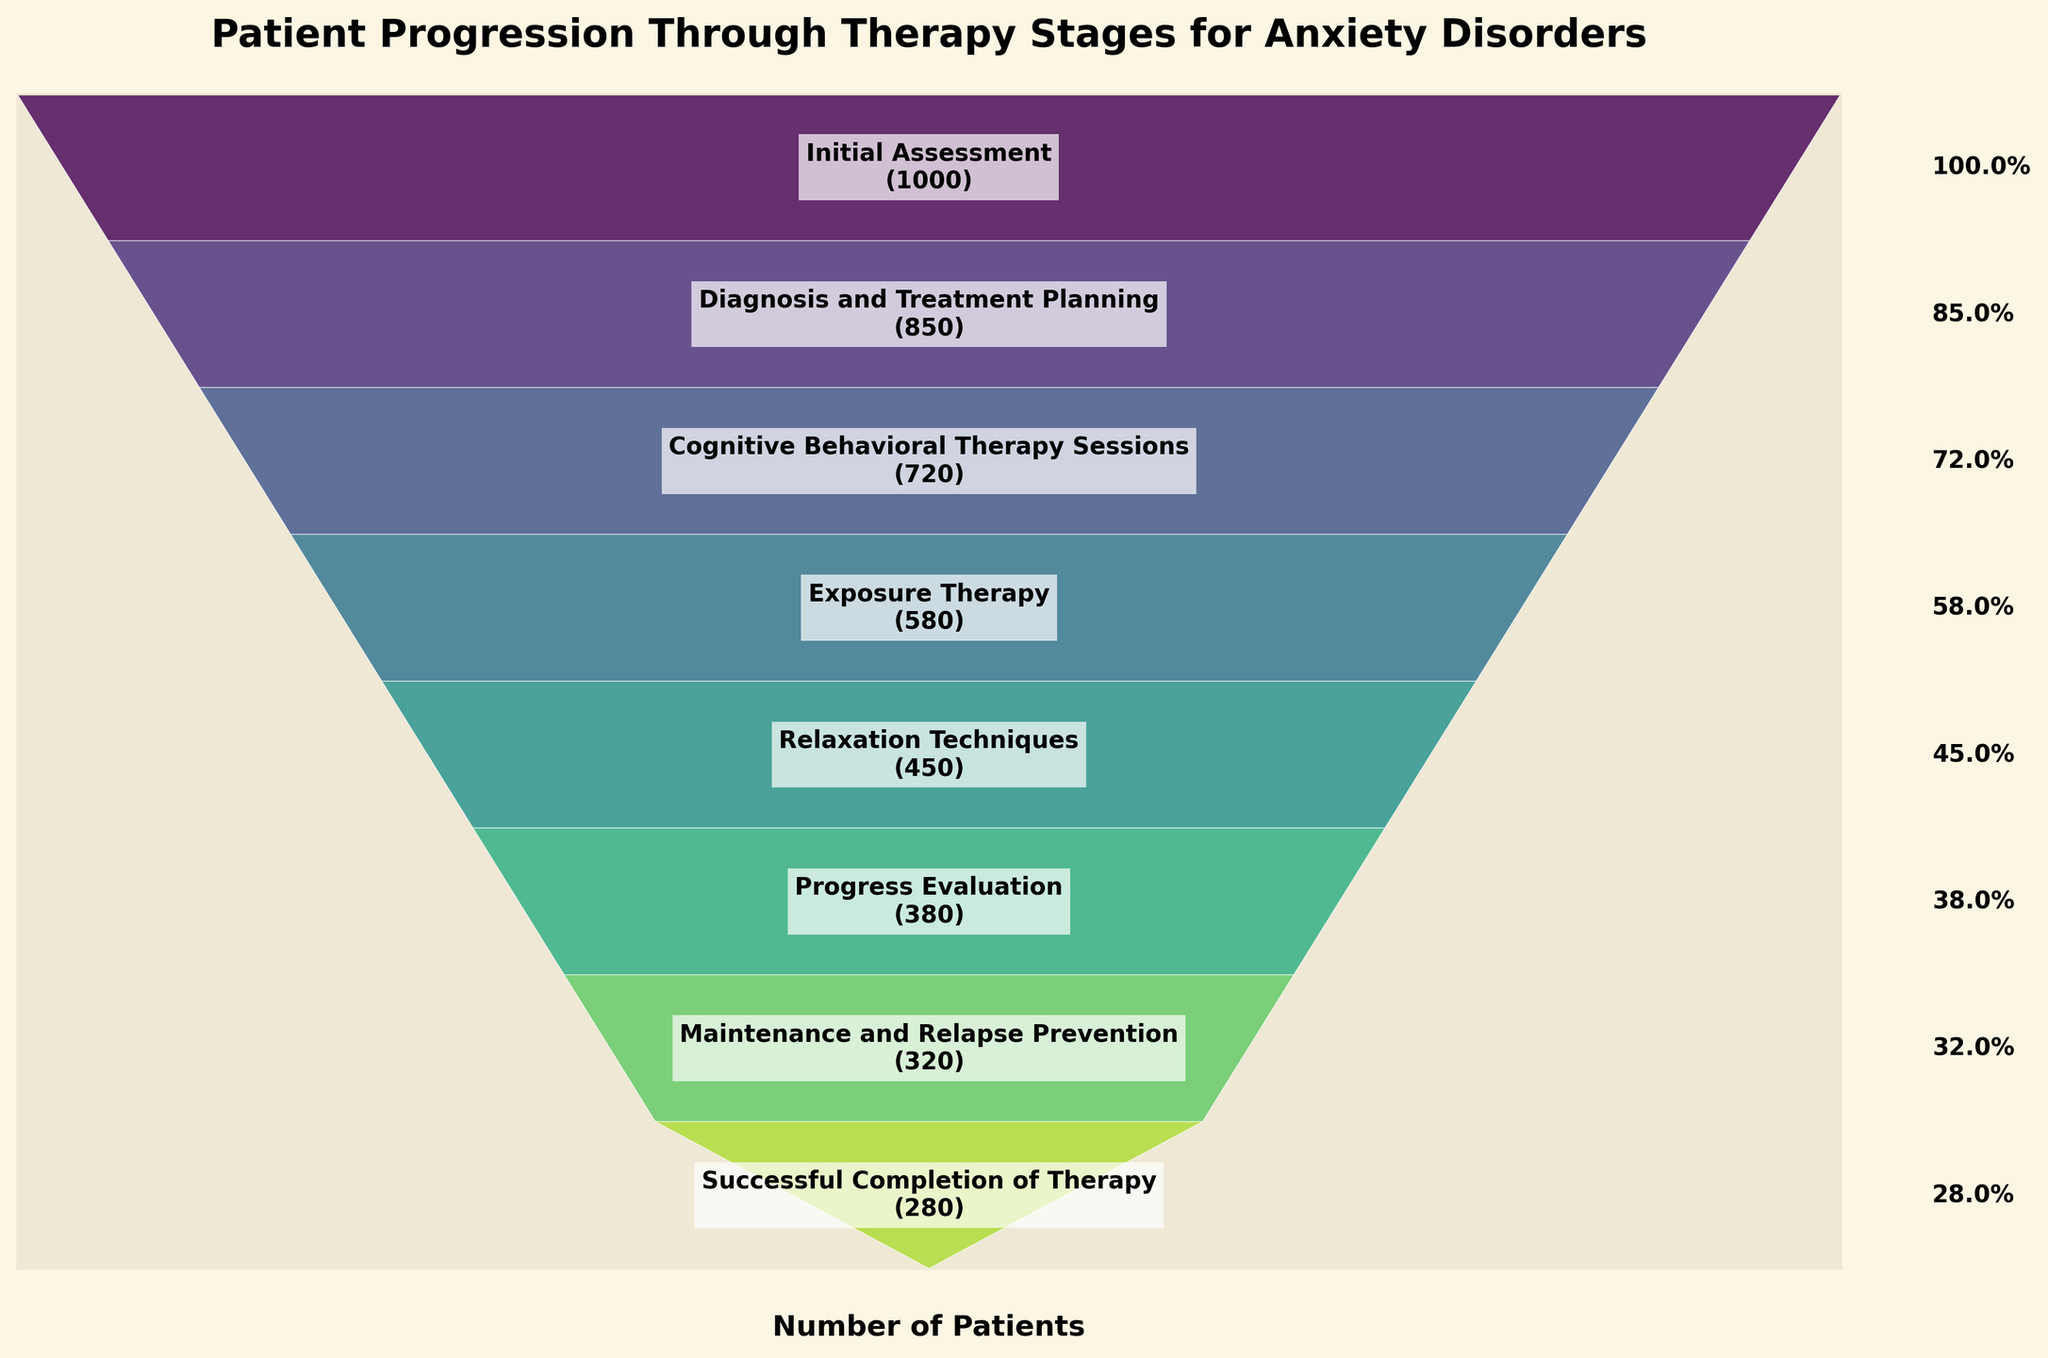What stage has the highest number of patients? The highest number of patients is shown at the first stage which is "Initial Assessment" with 1000 patients.
Answer: Initial Assessment How many patients are at the "Exposure Therapy" stage compared to the "Relaxation Techniques" stage? The number of patients at "Exposure Therapy" is 580 while at "Relaxation Techniques" it is 450. To compare, 580 is more than 450.
Answer: 580 vs 450 What percentage of patients complete the "Diagnosis and Treatment Planning" stage? "Diagnosis and Treatment Planning" has 850 patients. To find the percentage of patients that complete this stage out of the initial 1000, we use (850 / 1000) * 100. This equals 85%.
Answer: 85% How many patients transitioned from "Progress Evaluation" to the final stage? There were 380 patients at "Progress Evaluation" and 280 patients completed therapy. So, the number of those who transitioned is 380 - 280 = 100.
Answer: 100 What's the drop-off rate from "Initial Assessment" to "Successful Completion of Therapy"? From "Initial Assessment" (1000) to "Successful Completion of Therapy" (280), the drop-off rate is calculated as (1000 - 280) / 1000 * 100, which equals 72%.
Answer: 72% Which stage has the lowest patient retention? "Successful Completion of Therapy" has the lowest patient retention with 280 patients.
Answer: Successful Completion of Therapy What is the difference in the number of patients between the "Cognitive Behavioral Therapy Sessions" and "Maintenance and Relapse Prevention" stages? "Cognitive Behavioral Therapy Sessions" has 720 patients and "Maintenance and Relapse Prevention" has 320 patients. The difference is 720 - 320 = 400.
Answer: 400 How does the number of patients at "Exposure Therapy" compare to "Cognitive Behavioral Therapy Sessions"? There are 580 patients at "Exposure Therapy" and 720 patients at "Cognitive Behavioral Therapy Sessions". Comparing them, 580 is less than 720.
Answer: Less What is the trend of patient count as they progress through the stages? The trend shows a consistent drop in the number of patients as they progress through the stages from initial assessment to successful completion of therapy.
Answer: Consistent Drop What is the percentage decrease in patients from "Cognitive Behavioral Therapy Sessions" to "Exposure Therapy"? "Cognitive Behavioral Therapy Sessions" has 720 patients and "Exposure Therapy" has 580 patients. Percentage decrease is calculated as [(720 - 580) / 720] * 100, which equals approximately 19.4%.
Answer: 19.4% 